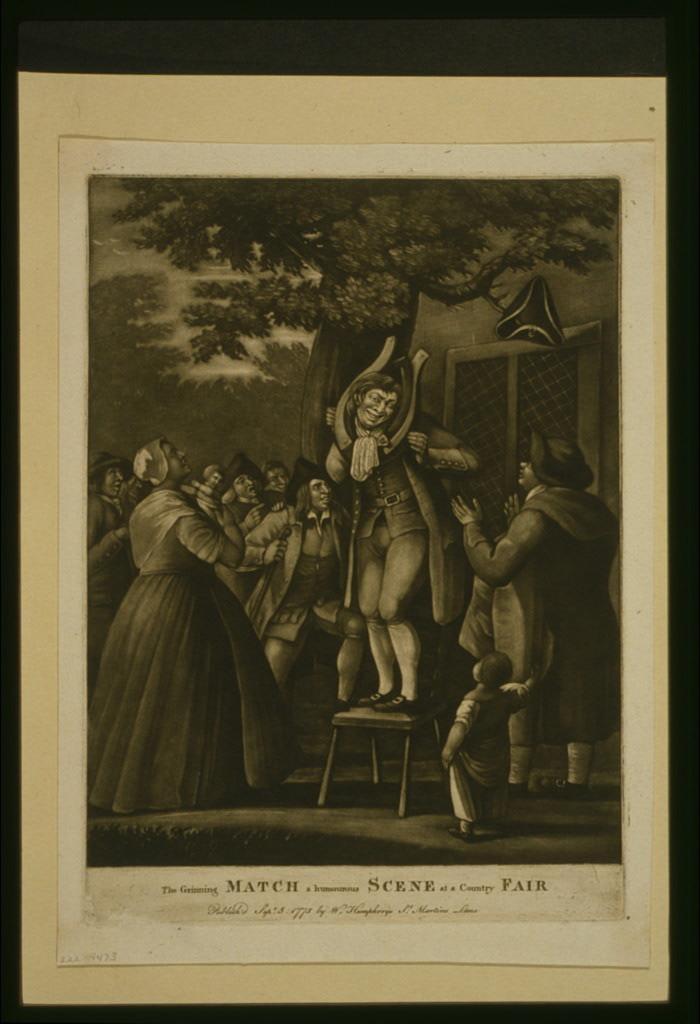Can you describe this image briefly? In the center of the image there is a poster. There are people in it. At the bottom of the image there is text. 